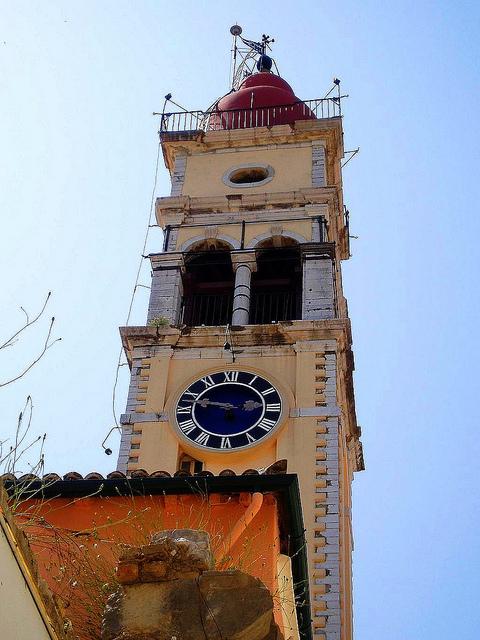What is the shape of the clock?
Keep it brief. Circle. Is this a sunny day?
Quick response, please. Yes. Is this a tower?
Give a very brief answer. Yes. What time is on the clock?
Quick response, please. 3:45. 